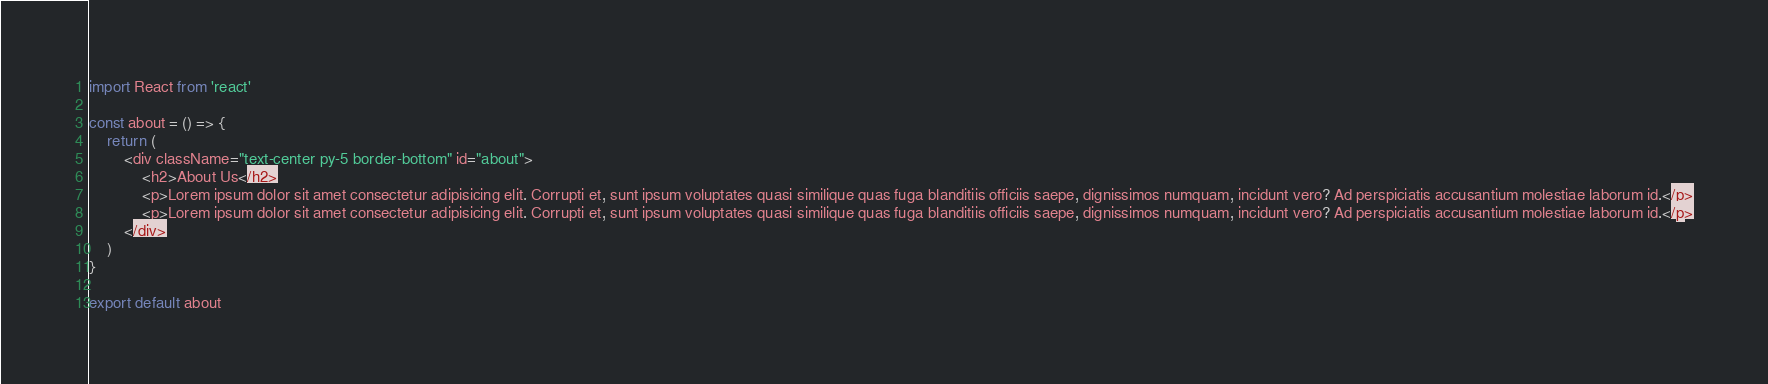Convert code to text. <code><loc_0><loc_0><loc_500><loc_500><_JavaScript_>import React from 'react'

const about = () => {
    return (
        <div className="text-center py-5 border-bottom" id="about">
            <h2>About Us</h2>
            <p>Lorem ipsum dolor sit amet consectetur adipisicing elit. Corrupti et, sunt ipsum voluptates quasi similique quas fuga blanditiis officiis saepe, dignissimos numquam, incidunt vero? Ad perspiciatis accusantium molestiae laborum id.</p>
            <p>Lorem ipsum dolor sit amet consectetur adipisicing elit. Corrupti et, sunt ipsum voluptates quasi similique quas fuga blanditiis officiis saepe, dignissimos numquam, incidunt vero? Ad perspiciatis accusantium molestiae laborum id.</p>
        </div>
    )
}

export default about
</code> 